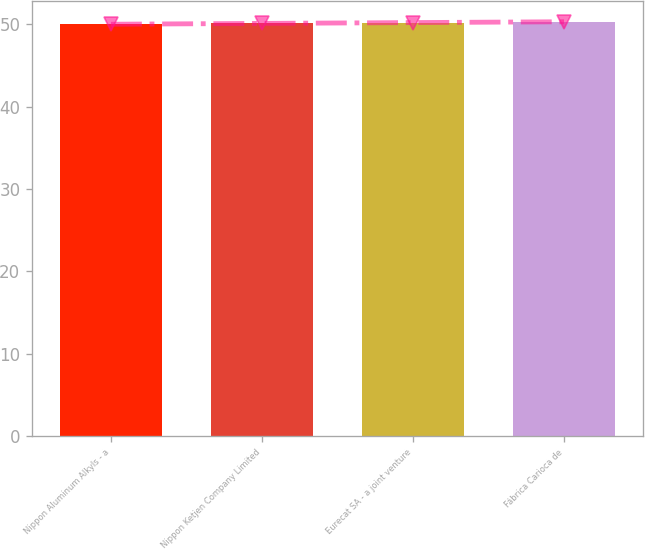Convert chart to OTSL. <chart><loc_0><loc_0><loc_500><loc_500><bar_chart><fcel>Nippon Aluminum Alkyls - a<fcel>Nippon Ketjen Company Limited<fcel>Eurecat SA - a joint venture<fcel>Fábrica Carioca de<nl><fcel>50<fcel>50.1<fcel>50.2<fcel>50.3<nl></chart> 